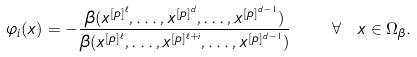<formula> <loc_0><loc_0><loc_500><loc_500>\varphi _ { i } ( x ) = - \frac { \beta ( x ^ { [ p ] ^ { \ell } } , \dots , x ^ { [ p ] ^ { d } } , \dots , x ^ { [ p ] ^ { d - 1 } } ) } { \beta ( x ^ { [ p ] ^ { \ell } } , \dots , x ^ { [ p ] ^ { \ell + i } } , \dots , x ^ { [ p ] ^ { d - 1 } } ) } \quad \forall \ x \in \Omega _ { \beta } .</formula> 